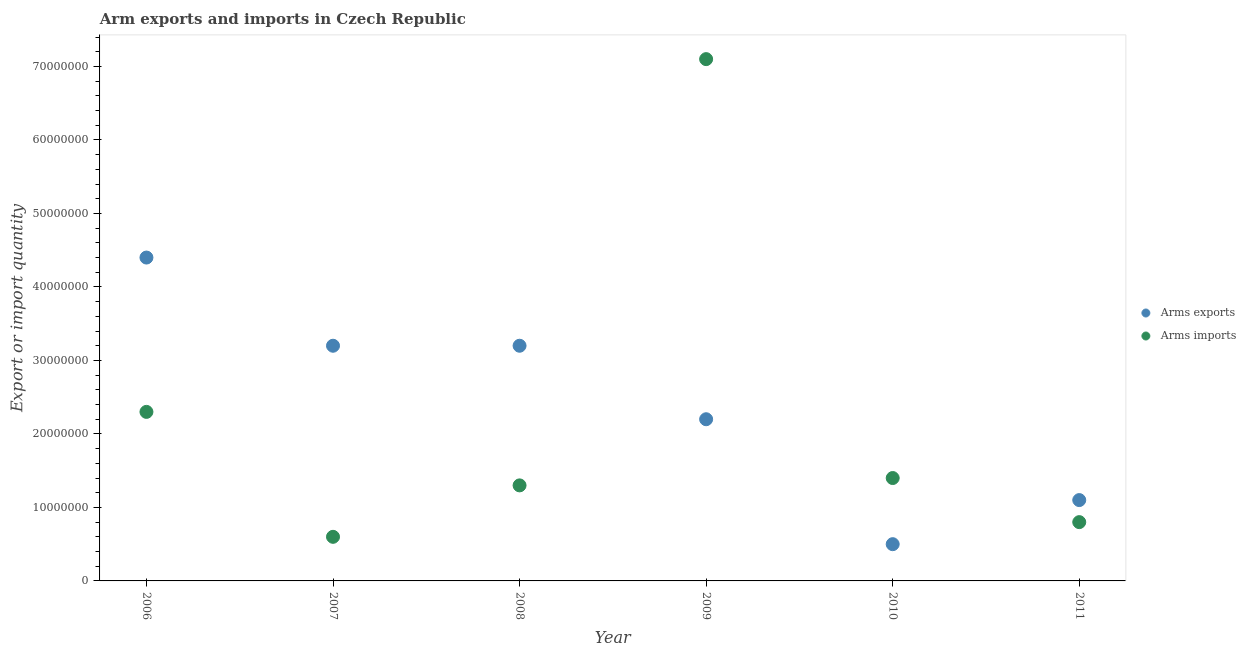Is the number of dotlines equal to the number of legend labels?
Make the answer very short. Yes. What is the arms imports in 2008?
Ensure brevity in your answer.  1.30e+07. Across all years, what is the maximum arms exports?
Give a very brief answer. 4.40e+07. Across all years, what is the minimum arms imports?
Offer a very short reply. 6.00e+06. What is the total arms exports in the graph?
Your answer should be very brief. 1.46e+08. What is the difference between the arms exports in 2007 and that in 2009?
Offer a terse response. 1.00e+07. What is the difference between the arms exports in 2007 and the arms imports in 2010?
Keep it short and to the point. 1.80e+07. What is the average arms imports per year?
Offer a terse response. 2.25e+07. In the year 2010, what is the difference between the arms exports and arms imports?
Your answer should be compact. -9.00e+06. Is the arms exports in 2006 less than that in 2010?
Keep it short and to the point. No. Is the difference between the arms imports in 2007 and 2009 greater than the difference between the arms exports in 2007 and 2009?
Your response must be concise. No. What is the difference between the highest and the lowest arms exports?
Your response must be concise. 3.90e+07. Is the arms imports strictly greater than the arms exports over the years?
Offer a very short reply. No. What is the difference between two consecutive major ticks on the Y-axis?
Your response must be concise. 1.00e+07. Does the graph contain grids?
Offer a very short reply. No. How many legend labels are there?
Your answer should be very brief. 2. How are the legend labels stacked?
Ensure brevity in your answer.  Vertical. What is the title of the graph?
Make the answer very short. Arm exports and imports in Czech Republic. Does "Primary school" appear as one of the legend labels in the graph?
Offer a very short reply. No. What is the label or title of the Y-axis?
Provide a succinct answer. Export or import quantity. What is the Export or import quantity in Arms exports in 2006?
Offer a very short reply. 4.40e+07. What is the Export or import quantity in Arms imports in 2006?
Keep it short and to the point. 2.30e+07. What is the Export or import quantity of Arms exports in 2007?
Your answer should be very brief. 3.20e+07. What is the Export or import quantity of Arms imports in 2007?
Your answer should be very brief. 6.00e+06. What is the Export or import quantity of Arms exports in 2008?
Ensure brevity in your answer.  3.20e+07. What is the Export or import quantity in Arms imports in 2008?
Your answer should be very brief. 1.30e+07. What is the Export or import quantity in Arms exports in 2009?
Offer a terse response. 2.20e+07. What is the Export or import quantity of Arms imports in 2009?
Give a very brief answer. 7.10e+07. What is the Export or import quantity of Arms exports in 2010?
Make the answer very short. 5.00e+06. What is the Export or import quantity in Arms imports in 2010?
Give a very brief answer. 1.40e+07. What is the Export or import quantity of Arms exports in 2011?
Offer a terse response. 1.10e+07. What is the Export or import quantity of Arms imports in 2011?
Provide a succinct answer. 8.00e+06. Across all years, what is the maximum Export or import quantity in Arms exports?
Your response must be concise. 4.40e+07. Across all years, what is the maximum Export or import quantity of Arms imports?
Provide a short and direct response. 7.10e+07. Across all years, what is the minimum Export or import quantity in Arms exports?
Your answer should be compact. 5.00e+06. What is the total Export or import quantity in Arms exports in the graph?
Your response must be concise. 1.46e+08. What is the total Export or import quantity of Arms imports in the graph?
Give a very brief answer. 1.35e+08. What is the difference between the Export or import quantity of Arms exports in 2006 and that in 2007?
Ensure brevity in your answer.  1.20e+07. What is the difference between the Export or import quantity of Arms imports in 2006 and that in 2007?
Keep it short and to the point. 1.70e+07. What is the difference between the Export or import quantity of Arms exports in 2006 and that in 2008?
Your response must be concise. 1.20e+07. What is the difference between the Export or import quantity in Arms exports in 2006 and that in 2009?
Provide a short and direct response. 2.20e+07. What is the difference between the Export or import quantity in Arms imports in 2006 and that in 2009?
Ensure brevity in your answer.  -4.80e+07. What is the difference between the Export or import quantity in Arms exports in 2006 and that in 2010?
Provide a succinct answer. 3.90e+07. What is the difference between the Export or import quantity of Arms imports in 2006 and that in 2010?
Your answer should be compact. 9.00e+06. What is the difference between the Export or import quantity of Arms exports in 2006 and that in 2011?
Provide a short and direct response. 3.30e+07. What is the difference between the Export or import quantity in Arms imports in 2006 and that in 2011?
Offer a very short reply. 1.50e+07. What is the difference between the Export or import quantity in Arms imports in 2007 and that in 2008?
Keep it short and to the point. -7.00e+06. What is the difference between the Export or import quantity in Arms exports in 2007 and that in 2009?
Your answer should be very brief. 1.00e+07. What is the difference between the Export or import quantity of Arms imports in 2007 and that in 2009?
Keep it short and to the point. -6.50e+07. What is the difference between the Export or import quantity in Arms exports in 2007 and that in 2010?
Your answer should be very brief. 2.70e+07. What is the difference between the Export or import quantity of Arms imports in 2007 and that in 2010?
Make the answer very short. -8.00e+06. What is the difference between the Export or import quantity of Arms exports in 2007 and that in 2011?
Provide a short and direct response. 2.10e+07. What is the difference between the Export or import quantity in Arms imports in 2007 and that in 2011?
Offer a very short reply. -2.00e+06. What is the difference between the Export or import quantity in Arms imports in 2008 and that in 2009?
Ensure brevity in your answer.  -5.80e+07. What is the difference between the Export or import quantity of Arms exports in 2008 and that in 2010?
Keep it short and to the point. 2.70e+07. What is the difference between the Export or import quantity of Arms imports in 2008 and that in 2010?
Make the answer very short. -1.00e+06. What is the difference between the Export or import quantity of Arms exports in 2008 and that in 2011?
Ensure brevity in your answer.  2.10e+07. What is the difference between the Export or import quantity of Arms exports in 2009 and that in 2010?
Keep it short and to the point. 1.70e+07. What is the difference between the Export or import quantity in Arms imports in 2009 and that in 2010?
Ensure brevity in your answer.  5.70e+07. What is the difference between the Export or import quantity of Arms exports in 2009 and that in 2011?
Your answer should be very brief. 1.10e+07. What is the difference between the Export or import quantity in Arms imports in 2009 and that in 2011?
Provide a succinct answer. 6.30e+07. What is the difference between the Export or import quantity of Arms exports in 2010 and that in 2011?
Your answer should be very brief. -6.00e+06. What is the difference between the Export or import quantity of Arms imports in 2010 and that in 2011?
Ensure brevity in your answer.  6.00e+06. What is the difference between the Export or import quantity of Arms exports in 2006 and the Export or import quantity of Arms imports in 2007?
Keep it short and to the point. 3.80e+07. What is the difference between the Export or import quantity of Arms exports in 2006 and the Export or import quantity of Arms imports in 2008?
Your response must be concise. 3.10e+07. What is the difference between the Export or import quantity of Arms exports in 2006 and the Export or import quantity of Arms imports in 2009?
Keep it short and to the point. -2.70e+07. What is the difference between the Export or import quantity of Arms exports in 2006 and the Export or import quantity of Arms imports in 2010?
Ensure brevity in your answer.  3.00e+07. What is the difference between the Export or import quantity of Arms exports in 2006 and the Export or import quantity of Arms imports in 2011?
Offer a terse response. 3.60e+07. What is the difference between the Export or import quantity of Arms exports in 2007 and the Export or import quantity of Arms imports in 2008?
Ensure brevity in your answer.  1.90e+07. What is the difference between the Export or import quantity of Arms exports in 2007 and the Export or import quantity of Arms imports in 2009?
Provide a succinct answer. -3.90e+07. What is the difference between the Export or import quantity in Arms exports in 2007 and the Export or import quantity in Arms imports in 2010?
Your response must be concise. 1.80e+07. What is the difference between the Export or import quantity of Arms exports in 2007 and the Export or import quantity of Arms imports in 2011?
Ensure brevity in your answer.  2.40e+07. What is the difference between the Export or import quantity of Arms exports in 2008 and the Export or import quantity of Arms imports in 2009?
Provide a succinct answer. -3.90e+07. What is the difference between the Export or import quantity of Arms exports in 2008 and the Export or import quantity of Arms imports in 2010?
Your answer should be compact. 1.80e+07. What is the difference between the Export or import quantity in Arms exports in 2008 and the Export or import quantity in Arms imports in 2011?
Make the answer very short. 2.40e+07. What is the difference between the Export or import quantity of Arms exports in 2009 and the Export or import quantity of Arms imports in 2011?
Offer a very short reply. 1.40e+07. What is the average Export or import quantity of Arms exports per year?
Your response must be concise. 2.43e+07. What is the average Export or import quantity of Arms imports per year?
Your answer should be very brief. 2.25e+07. In the year 2006, what is the difference between the Export or import quantity in Arms exports and Export or import quantity in Arms imports?
Your answer should be compact. 2.10e+07. In the year 2007, what is the difference between the Export or import quantity of Arms exports and Export or import quantity of Arms imports?
Your response must be concise. 2.60e+07. In the year 2008, what is the difference between the Export or import quantity in Arms exports and Export or import quantity in Arms imports?
Give a very brief answer. 1.90e+07. In the year 2009, what is the difference between the Export or import quantity of Arms exports and Export or import quantity of Arms imports?
Offer a very short reply. -4.90e+07. In the year 2010, what is the difference between the Export or import quantity of Arms exports and Export or import quantity of Arms imports?
Provide a short and direct response. -9.00e+06. In the year 2011, what is the difference between the Export or import quantity of Arms exports and Export or import quantity of Arms imports?
Keep it short and to the point. 3.00e+06. What is the ratio of the Export or import quantity in Arms exports in 2006 to that in 2007?
Offer a terse response. 1.38. What is the ratio of the Export or import quantity of Arms imports in 2006 to that in 2007?
Keep it short and to the point. 3.83. What is the ratio of the Export or import quantity in Arms exports in 2006 to that in 2008?
Offer a very short reply. 1.38. What is the ratio of the Export or import quantity of Arms imports in 2006 to that in 2008?
Your answer should be compact. 1.77. What is the ratio of the Export or import quantity of Arms imports in 2006 to that in 2009?
Ensure brevity in your answer.  0.32. What is the ratio of the Export or import quantity of Arms imports in 2006 to that in 2010?
Provide a short and direct response. 1.64. What is the ratio of the Export or import quantity of Arms exports in 2006 to that in 2011?
Keep it short and to the point. 4. What is the ratio of the Export or import quantity of Arms imports in 2006 to that in 2011?
Give a very brief answer. 2.88. What is the ratio of the Export or import quantity in Arms exports in 2007 to that in 2008?
Keep it short and to the point. 1. What is the ratio of the Export or import quantity of Arms imports in 2007 to that in 2008?
Give a very brief answer. 0.46. What is the ratio of the Export or import quantity in Arms exports in 2007 to that in 2009?
Provide a short and direct response. 1.45. What is the ratio of the Export or import quantity of Arms imports in 2007 to that in 2009?
Your answer should be very brief. 0.08. What is the ratio of the Export or import quantity of Arms exports in 2007 to that in 2010?
Your answer should be very brief. 6.4. What is the ratio of the Export or import quantity in Arms imports in 2007 to that in 2010?
Provide a short and direct response. 0.43. What is the ratio of the Export or import quantity in Arms exports in 2007 to that in 2011?
Make the answer very short. 2.91. What is the ratio of the Export or import quantity of Arms exports in 2008 to that in 2009?
Ensure brevity in your answer.  1.45. What is the ratio of the Export or import quantity of Arms imports in 2008 to that in 2009?
Offer a very short reply. 0.18. What is the ratio of the Export or import quantity of Arms exports in 2008 to that in 2010?
Your response must be concise. 6.4. What is the ratio of the Export or import quantity in Arms imports in 2008 to that in 2010?
Offer a terse response. 0.93. What is the ratio of the Export or import quantity of Arms exports in 2008 to that in 2011?
Provide a short and direct response. 2.91. What is the ratio of the Export or import quantity in Arms imports in 2008 to that in 2011?
Offer a terse response. 1.62. What is the ratio of the Export or import quantity in Arms exports in 2009 to that in 2010?
Offer a terse response. 4.4. What is the ratio of the Export or import quantity in Arms imports in 2009 to that in 2010?
Ensure brevity in your answer.  5.07. What is the ratio of the Export or import quantity of Arms exports in 2009 to that in 2011?
Give a very brief answer. 2. What is the ratio of the Export or import quantity of Arms imports in 2009 to that in 2011?
Ensure brevity in your answer.  8.88. What is the ratio of the Export or import quantity in Arms exports in 2010 to that in 2011?
Keep it short and to the point. 0.45. What is the ratio of the Export or import quantity of Arms imports in 2010 to that in 2011?
Your answer should be very brief. 1.75. What is the difference between the highest and the second highest Export or import quantity of Arms imports?
Your response must be concise. 4.80e+07. What is the difference between the highest and the lowest Export or import quantity of Arms exports?
Offer a very short reply. 3.90e+07. What is the difference between the highest and the lowest Export or import quantity of Arms imports?
Keep it short and to the point. 6.50e+07. 